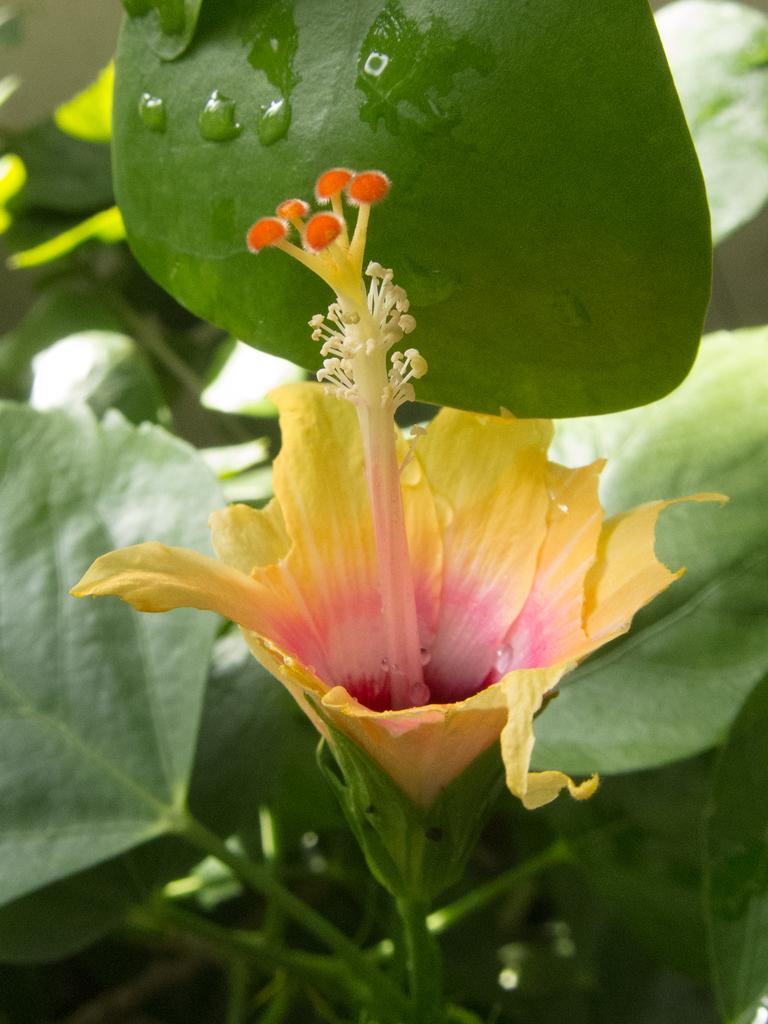What type of living organisms can be seen in the image? Plants can be seen in the image. What specific features can be observed on the plants? The plants have flowers, and the flowers are yellow and pink in color. What else can be seen on the plants besides flowers? There are leaves in the image. Can you describe the condition of the leaves? There are water droplets on the leaves. What type of pan is being used to provide comfort to the plants in the image? There is no pan present in the image, and the plants do not require comfort. 